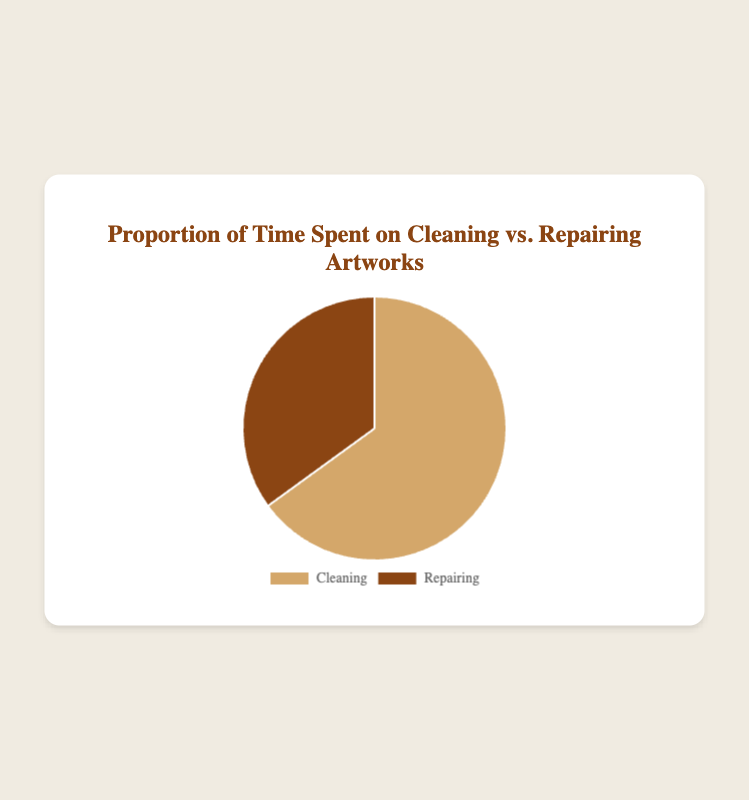What proportion of time is spent on cleaning? The figure shows a pie chart with two segments. The segment labeled "Cleaning" corresponds to 65% of the total time.
Answer: 65% What task takes up 35% of the total time? The pie chart shows that the "Repairing" segment corresponds to 35% of the total time.
Answer: Repairing Is more time spent on cleaning or repairing? In the pie chart, the "Cleaning" segment is larger and represents 65% of the time, whereas "Repairing" represents 35%. Therefore, more time is spent on cleaning.
Answer: Cleaning How much more time is spent on cleaning compared to repairing? From the pie chart, cleaning takes up 65% and repairing takes up 35%. The difference is 65% - 35% = 30%.
Answer: 30% If you spent 8 hours on artwork restoration, how many hours were likely spent on cleaning? 65% of 8 hours is calculated by taking 0.65 * 8 = 5.2 hours.
Answer: 5.2 hours What is the ratio of time spent on cleaning to time spent on repairing? The time spent on cleaning is 65% and on repairing is 35%. The ratio is 65:35, which simplifies to approximately 13:7.
Answer: 13:7 Which segment in the pie chart is visually larger and what percentage does it represent? The "Cleaning" segment is visually larger and represents 65% of the total time.
Answer: Cleaning, 65% By how many percentage points does cleaning exceed repairing in time allocation? Cleaning is 65% and repairing is 35%. The difference is 65% - 35% = 30 percentage points.
Answer: 30 percentage points What are the tasks included in the pie chart for time distribution? The pie chart includes two tasks: "Cleaning" and "Repairing."
Answer: Cleaning and Repairing What is the combined percentage of time spent on cleaning and repairing? The combined percentage is 65% for cleaning and 35% for repairing, which sums to 65% + 35% = 100%.
Answer: 100% 